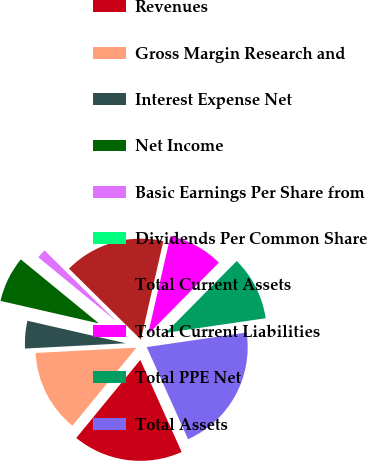<chart> <loc_0><loc_0><loc_500><loc_500><pie_chart><fcel>Revenues<fcel>Gross Margin Research and<fcel>Interest Expense Net<fcel>Net Income<fcel>Basic Earnings Per Share from<fcel>Dividends Per Common Share<fcel>Total Current Assets<fcel>Total Current Liabilities<fcel>Total PPE Net<fcel>Total Assets<nl><fcel>17.65%<fcel>13.23%<fcel>4.41%<fcel>7.35%<fcel>1.47%<fcel>0.0%<fcel>16.18%<fcel>8.82%<fcel>10.29%<fcel>20.59%<nl></chart> 